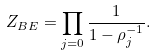Convert formula to latex. <formula><loc_0><loc_0><loc_500><loc_500>Z _ { B E } = \prod _ { j = 0 } \frac { 1 } { 1 - \rho _ { j } ^ { - 1 } } .</formula> 